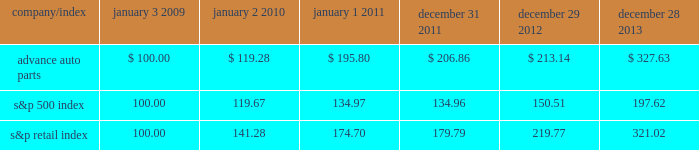Stock price performance the following graph shows a comparison of the cumulative total return on our common stock , the standard & poor 2019s 500 index and the standard & poor 2019s retail index .
The graph assumes that the value of an investment in our common stock and in each such index was $ 100 on january 3 , 2009 , and that any dividends have been reinvested .
The comparison in the graph below is based solely on historical data and is not intended to forecast the possible future performance of our common stock .
Comparison of cumulative total return among advance auto parts , inc. , s&p 500 index and s&p retail index company/index january 3 , january 2 , january 1 , december 31 , december 29 , december 28 .

From 2009 to 2012 , what percentage return did advance auto parts beat the overall market? 
Rationale: to find the return for both stocks one would calculate the amount the company changed from 2009 to 2012 in a percentage . then take the answers for both the companies and subtract them from each other .
Computations: ((213.14 - 100) - (150.51 - 100))
Answer: 62.63. 